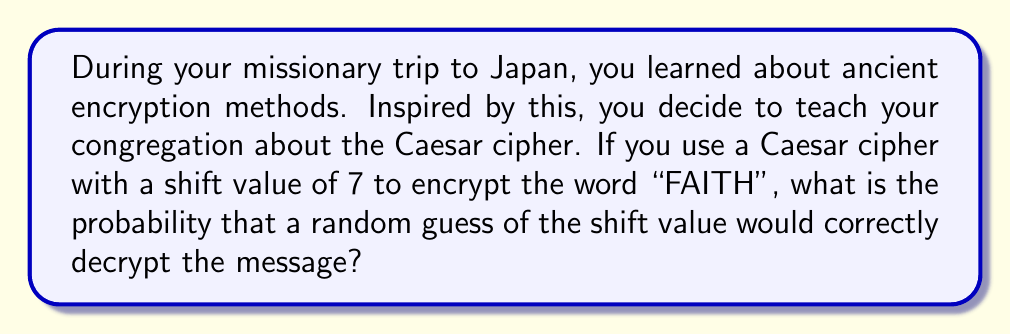Teach me how to tackle this problem. Let's approach this step-by-step:

1) First, we need to understand what a Caesar cipher is. It's a simple substitution cipher where each letter in the plaintext is shifted a certain number of positions down the alphabet.

2) In this case, the shift value is 7. So, "FAITH" would be encrypted as:
   F → M
   A → H
   I → P
   T → A
   H → O
   
   The encrypted message is "MHPAO".

3) To decrypt, one needs to guess the correct shift value. In the English alphabet, there are 26 possible shift values (0 to 25, where 0 means no shift).

4) The probability of guessing the correct shift value is:

   $$P(\text{correct guess}) = \frac{\text{number of favorable outcomes}}{\text{total number of possible outcomes}}$$

5) In this case:
   - There is only 1 correct shift value (7)
   - There are 26 possible shift values in total

6) Therefore, the probability is:

   $$P(\text{correct guess}) = \frac{1}{26}$$

This can be expressed as a fraction (1/26), a decimal (approximately 0.0385), or a percentage (approximately 3.85%).
Answer: $\frac{1}{26}$ 